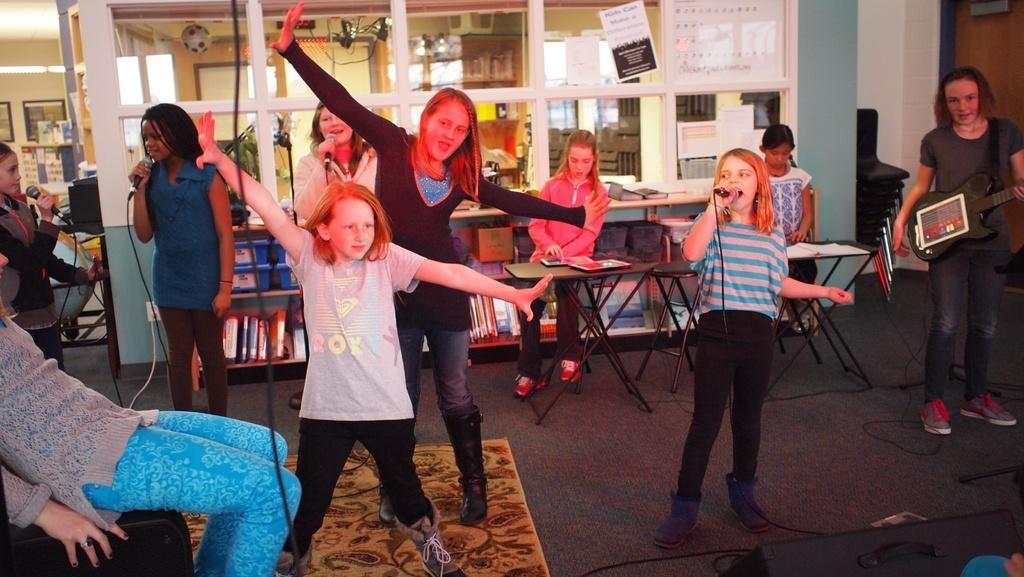Describe this image in one or two sentences. In this image few people are dancing ,few are singing, few are playing musical instrument. In the background there are tables and chairs. In the floor there is carpet. 